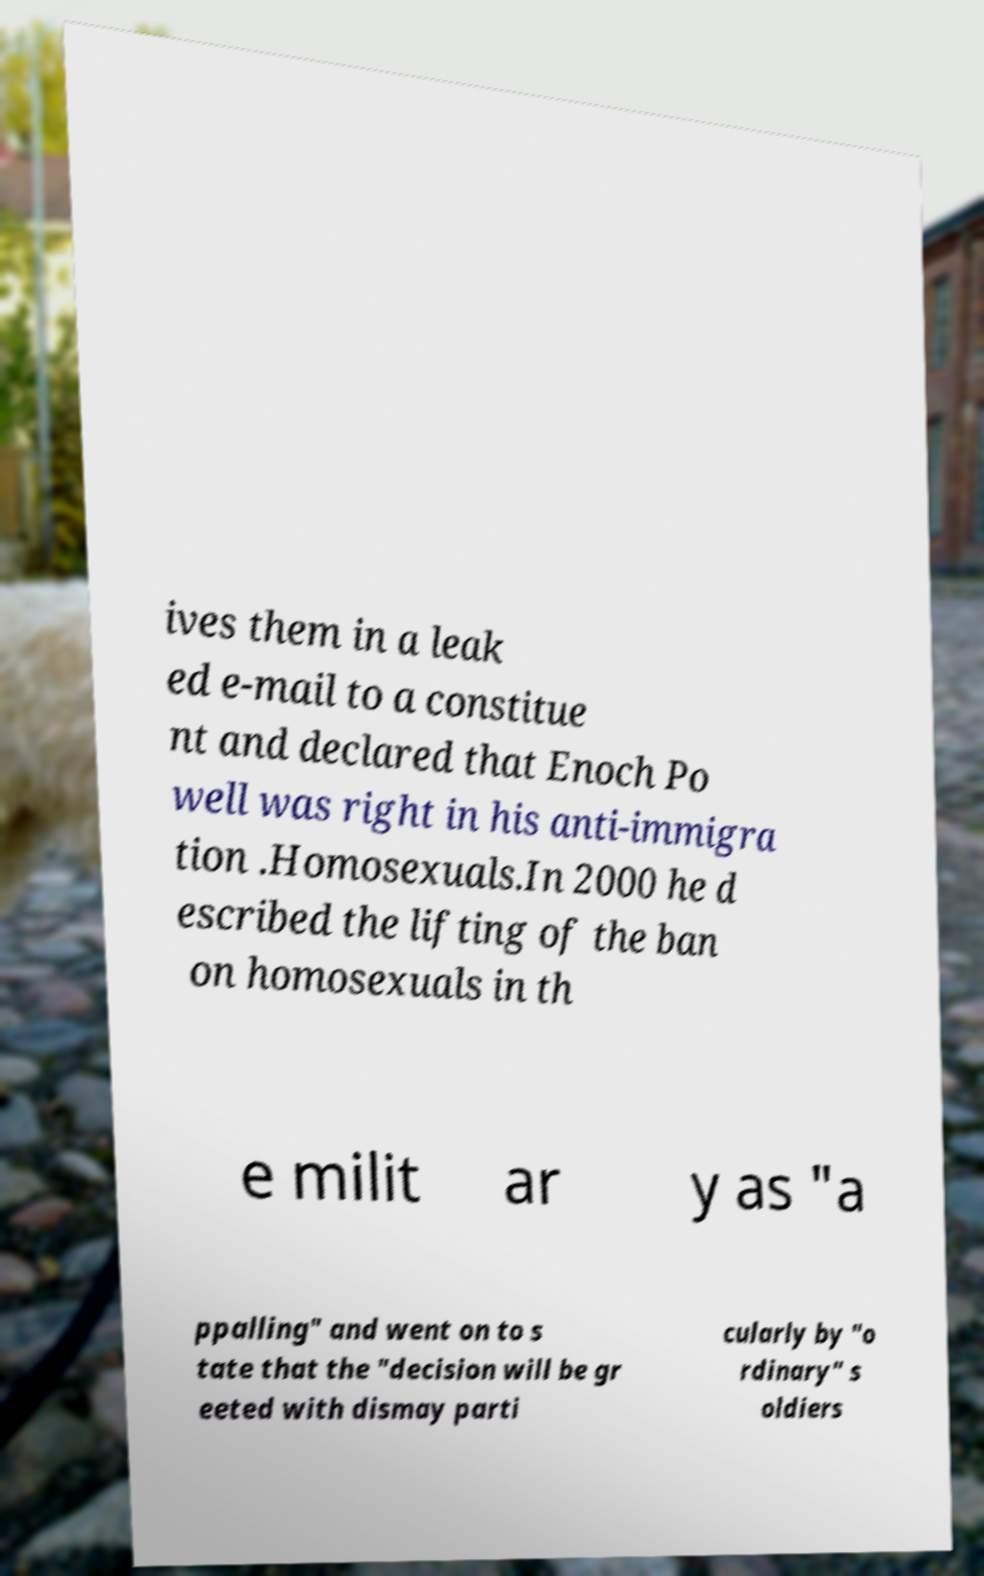I need the written content from this picture converted into text. Can you do that? ives them in a leak ed e-mail to a constitue nt and declared that Enoch Po well was right in his anti-immigra tion .Homosexuals.In 2000 he d escribed the lifting of the ban on homosexuals in th e milit ar y as "a ppalling" and went on to s tate that the "decision will be gr eeted with dismay parti cularly by "o rdinary" s oldiers 